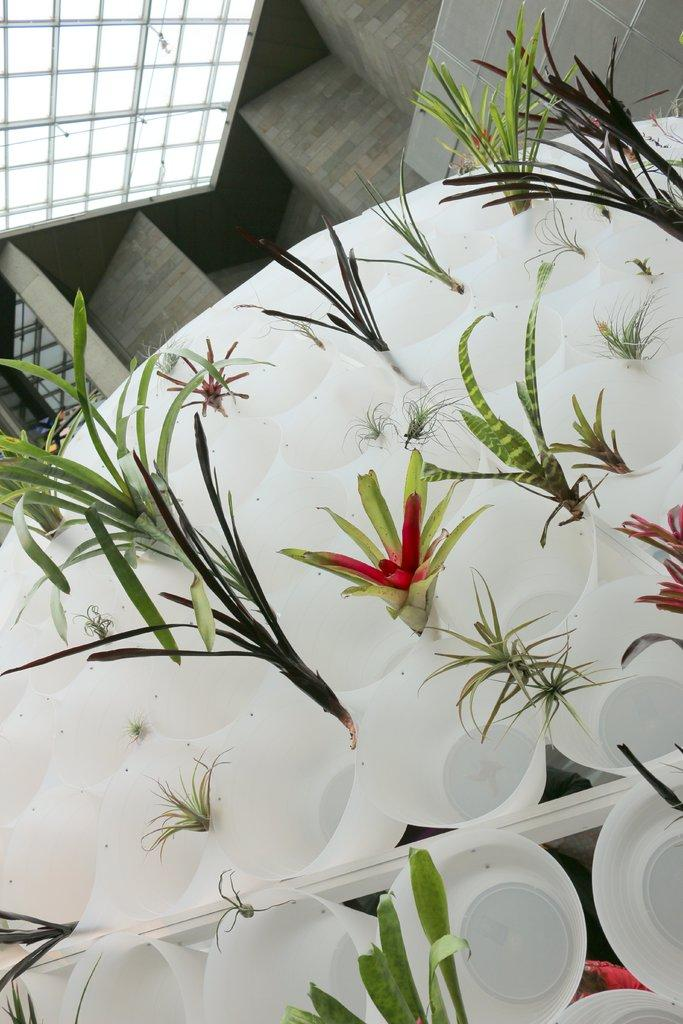What type of cups are visible in the image? There are white colored cups in the image. What is inside the cups? There are plants in the cups. What colors can be seen on the plants? The plants have green, red, and pink colors. What can be seen in the background of the image? There is a wall and a ceiling in the background of the image. What scent is emitted by the cups in the image? There is no information about the scent of the cups or the plants in the image. 